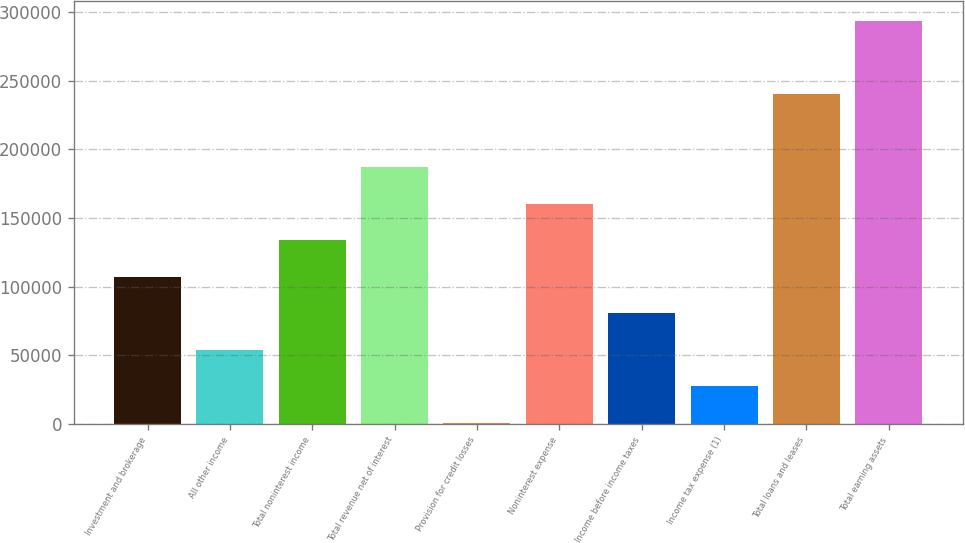Convert chart. <chart><loc_0><loc_0><loc_500><loc_500><bar_chart><fcel>Investment and brokerage<fcel>All other income<fcel>Total noninterest income<fcel>Total revenue net of interest<fcel>Provision for credit losses<fcel>Noninterest expense<fcel>Income before income taxes<fcel>Income tax expense (1)<fcel>Total loans and leases<fcel>Total earning assets<nl><fcel>107043<fcel>53844.4<fcel>133642<fcel>186840<fcel>646<fcel>160241<fcel>80443.6<fcel>27245.2<fcel>240039<fcel>293237<nl></chart> 